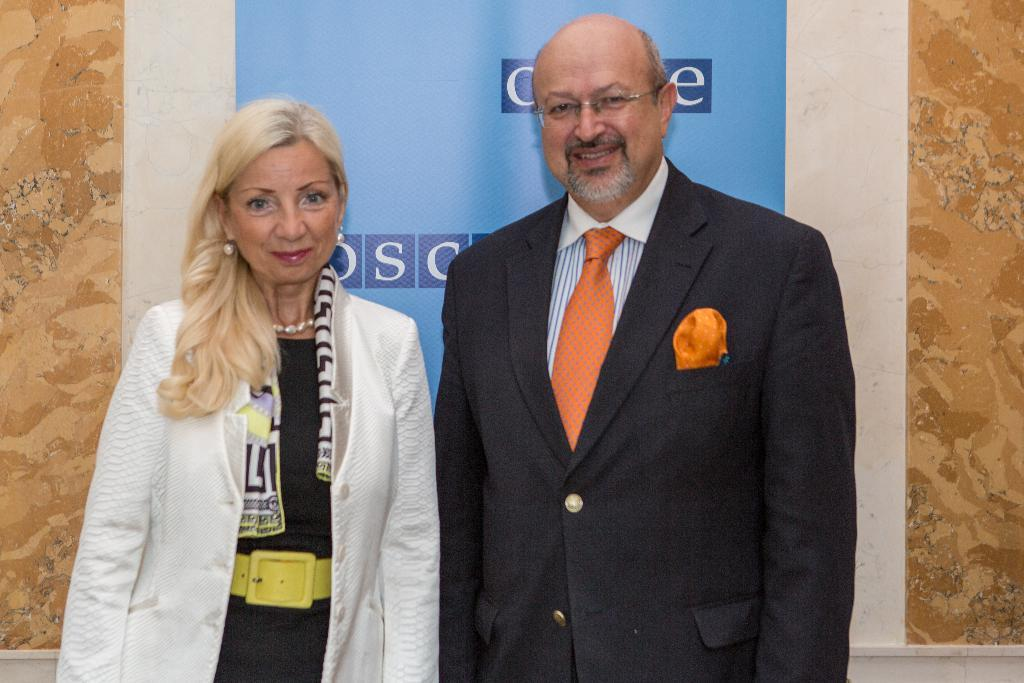How many people are present in the image? There are two people in the image. What expressions do the people have on their faces? The people are wearing smiles on their faces. What can be seen in the background of the image? There is a wall in the background of the image. What is attached to the wall in the image? A poster is attached to the wall. What type of bread is being served in the class in the image? There is no class or bread present in the image; it features two people smiling and a wall with a poster. 